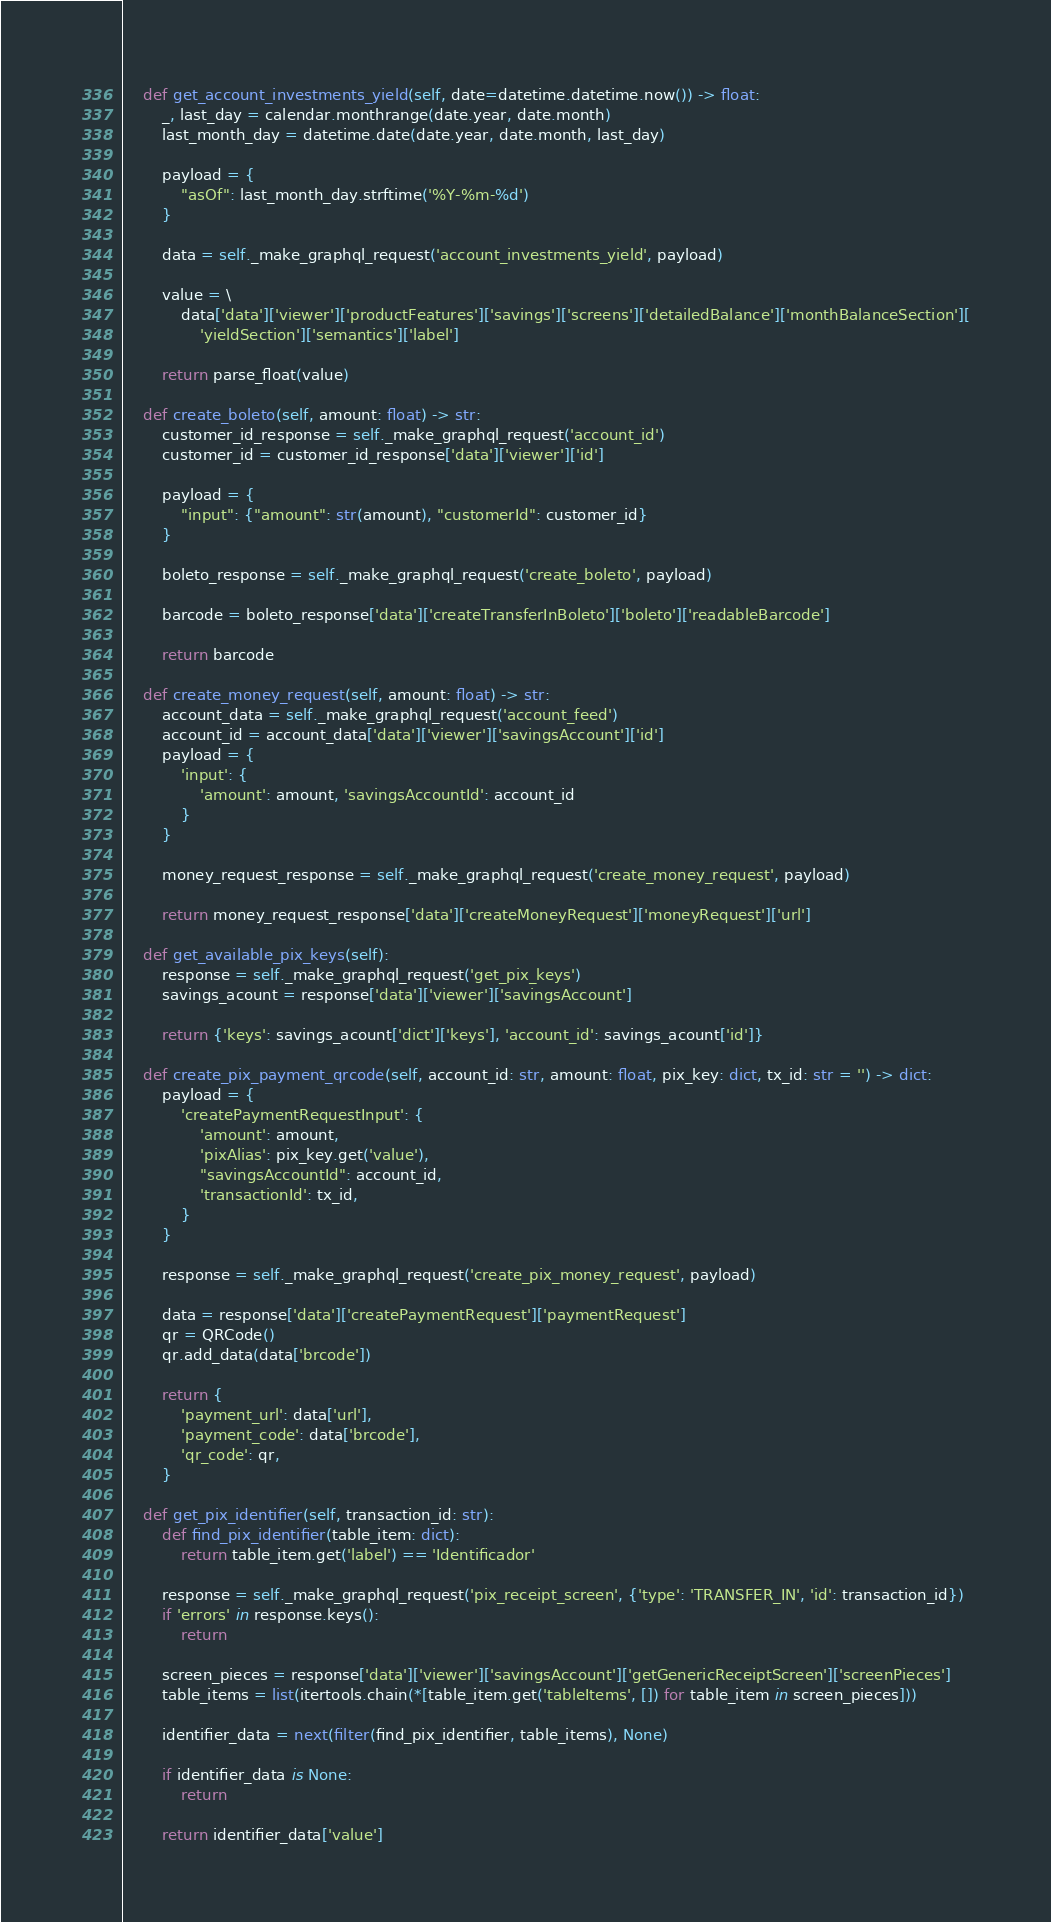<code> <loc_0><loc_0><loc_500><loc_500><_Python_>
    def get_account_investments_yield(self, date=datetime.datetime.now()) -> float:
        _, last_day = calendar.monthrange(date.year, date.month)
        last_month_day = datetime.date(date.year, date.month, last_day)

        payload = {
            "asOf": last_month_day.strftime('%Y-%m-%d')
        }

        data = self._make_graphql_request('account_investments_yield', payload)

        value = \
            data['data']['viewer']['productFeatures']['savings']['screens']['detailedBalance']['monthBalanceSection'][
                'yieldSection']['semantics']['label']

        return parse_float(value)

    def create_boleto(self, amount: float) -> str:
        customer_id_response = self._make_graphql_request('account_id')
        customer_id = customer_id_response['data']['viewer']['id']

        payload = {
            "input": {"amount": str(amount), "customerId": customer_id}
        }

        boleto_response = self._make_graphql_request('create_boleto', payload)

        barcode = boleto_response['data']['createTransferInBoleto']['boleto']['readableBarcode']

        return barcode

    def create_money_request(self, amount: float) -> str:
        account_data = self._make_graphql_request('account_feed')
        account_id = account_data['data']['viewer']['savingsAccount']['id']
        payload = {
            'input': {
                'amount': amount, 'savingsAccountId': account_id
            }
        }

        money_request_response = self._make_graphql_request('create_money_request', payload)

        return money_request_response['data']['createMoneyRequest']['moneyRequest']['url']

    def get_available_pix_keys(self):
        response = self._make_graphql_request('get_pix_keys')
        savings_acount = response['data']['viewer']['savingsAccount']

        return {'keys': savings_acount['dict']['keys'], 'account_id': savings_acount['id']}

    def create_pix_payment_qrcode(self, account_id: str, amount: float, pix_key: dict, tx_id: str = '') -> dict:
        payload = {
            'createPaymentRequestInput': {
                'amount': amount,
                'pixAlias': pix_key.get('value'),
                "savingsAccountId": account_id,
                'transactionId': tx_id,
            }
        }

        response = self._make_graphql_request('create_pix_money_request', payload)

        data = response['data']['createPaymentRequest']['paymentRequest']
        qr = QRCode()
        qr.add_data(data['brcode'])

        return {
            'payment_url': data['url'],
            'payment_code': data['brcode'],
            'qr_code': qr,
        }

    def get_pix_identifier(self, transaction_id: str):
        def find_pix_identifier(table_item: dict):
            return table_item.get('label') == 'Identificador'

        response = self._make_graphql_request('pix_receipt_screen', {'type': 'TRANSFER_IN', 'id': transaction_id})
        if 'errors' in response.keys():
            return

        screen_pieces = response['data']['viewer']['savingsAccount']['getGenericReceiptScreen']['screenPieces']
        table_items = list(itertools.chain(*[table_item.get('tableItems', []) for table_item in screen_pieces]))

        identifier_data = next(filter(find_pix_identifier, table_items), None)

        if identifier_data is None:
            return

        return identifier_data['value']
</code> 